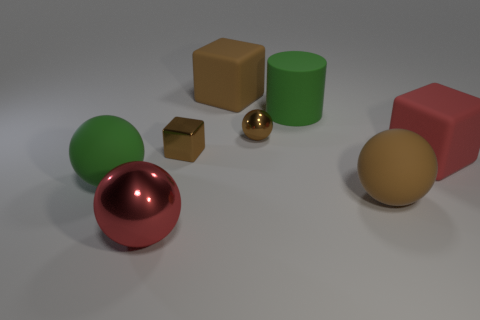Add 2 red metallic things. How many objects exist? 10 Subtract all cylinders. How many objects are left? 7 Subtract 0 cyan blocks. How many objects are left? 8 Subtract all shiny spheres. Subtract all tiny brown spheres. How many objects are left? 5 Add 6 tiny spheres. How many tiny spheres are left? 7 Add 3 large green rubber cylinders. How many large green rubber cylinders exist? 4 